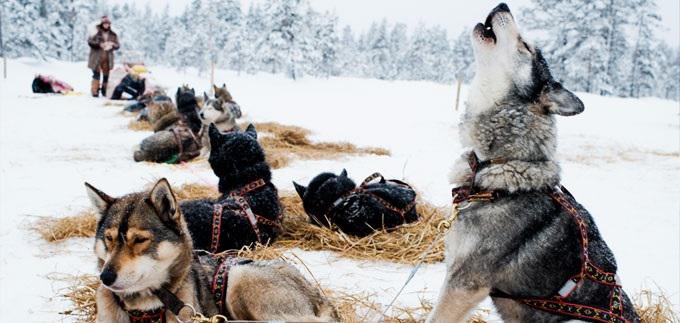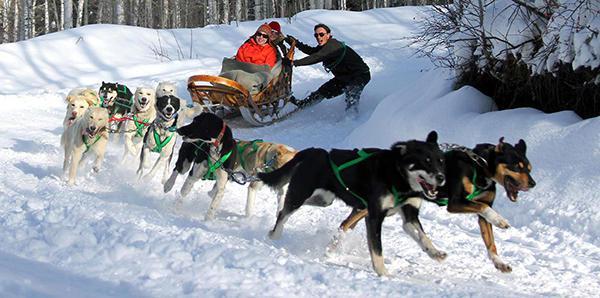The first image is the image on the left, the second image is the image on the right. Considering the images on both sides, is "A dog team led by two dark dogs is racing rightward and pulling a sled with at least one passenger." valid? Answer yes or no. Yes. The first image is the image on the left, the second image is the image on the right. Examine the images to the left and right. Is the description "In at least one image there are two adults once laying in the sled and the other holding on as at least six dogs are running right." accurate? Answer yes or no. Yes. 